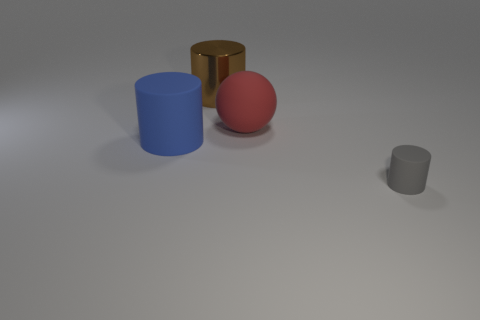Is there anything else that has the same material as the brown thing?
Provide a short and direct response. No. Is the size of the matte cylinder that is left of the gray matte cylinder the same as the big brown shiny cylinder?
Your answer should be very brief. Yes. Is there a big rubber sphere that has the same color as the small object?
Your answer should be very brief. No. There is a blue object that is the same material as the big red ball; what size is it?
Ensure brevity in your answer.  Large. Are there more metal things that are in front of the large red matte ball than large blue things to the right of the gray cylinder?
Your answer should be compact. No. What number of other things are there of the same material as the large blue cylinder
Provide a short and direct response. 2. Do the cylinder that is in front of the large blue thing and the big brown cylinder have the same material?
Offer a very short reply. No. The gray rubber object has what shape?
Keep it short and to the point. Cylinder. Is the number of gray objects that are behind the brown shiny cylinder greater than the number of metallic objects?
Your response must be concise. No. Are there any other things that have the same shape as the small thing?
Offer a terse response. Yes. 